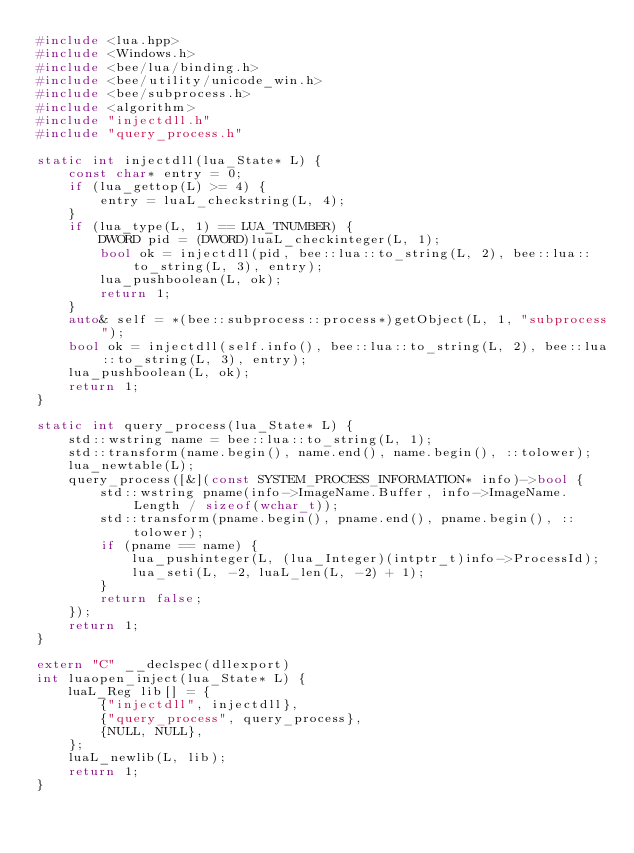Convert code to text. <code><loc_0><loc_0><loc_500><loc_500><_C++_>#include <lua.hpp>
#include <Windows.h>
#include <bee/lua/binding.h>
#include <bee/utility/unicode_win.h>
#include <bee/subprocess.h>
#include <algorithm>
#include "injectdll.h"
#include "query_process.h"

static int injectdll(lua_State* L) {
    const char* entry = 0;
    if (lua_gettop(L) >= 4) {
        entry = luaL_checkstring(L, 4);
    }
    if (lua_type(L, 1) == LUA_TNUMBER) {
        DWORD pid = (DWORD)luaL_checkinteger(L, 1);
        bool ok = injectdll(pid, bee::lua::to_string(L, 2), bee::lua::to_string(L, 3), entry);
        lua_pushboolean(L, ok);
        return 1;
    }
    auto& self = *(bee::subprocess::process*)getObject(L, 1, "subprocess");
    bool ok = injectdll(self.info(), bee::lua::to_string(L, 2), bee::lua::to_string(L, 3), entry);
    lua_pushboolean(L, ok);
    return 1;
}

static int query_process(lua_State* L) {
	std::wstring name = bee::lua::to_string(L, 1);
	std::transform(name.begin(), name.end(), name.begin(), ::tolower);
    lua_newtable(L);
	query_process([&](const SYSTEM_PROCESS_INFORMATION* info)->bool {
		std::wstring pname(info->ImageName.Buffer, info->ImageName.Length / sizeof(wchar_t));
		std::transform(pname.begin(), pname.end(), pname.begin(), ::tolower);
		if (pname == name) {
            lua_pushinteger(L, (lua_Integer)(intptr_t)info->ProcessId);
            lua_seti(L, -2, luaL_len(L, -2) + 1);
		}
		return false;
	});
    return 1;
}

extern "C" __declspec(dllexport)
int luaopen_inject(lua_State* L) {
    luaL_Reg lib[] = {
        {"injectdll", injectdll},
        {"query_process", query_process},
        {NULL, NULL},
    };
    luaL_newlib(L, lib);
    return 1;
}
</code> 